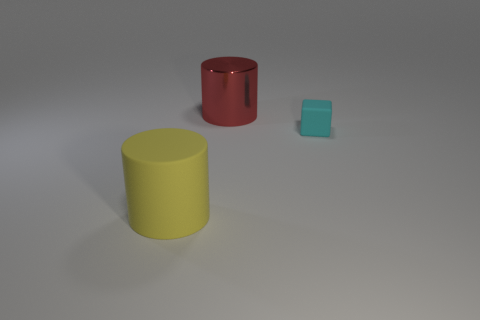Add 2 cyan matte blocks. How many objects exist? 5 Subtract all cylinders. How many objects are left? 1 Subtract all large balls. Subtract all metallic things. How many objects are left? 2 Add 2 cyan rubber things. How many cyan rubber things are left? 3 Add 1 brown balls. How many brown balls exist? 1 Subtract 0 gray cylinders. How many objects are left? 3 